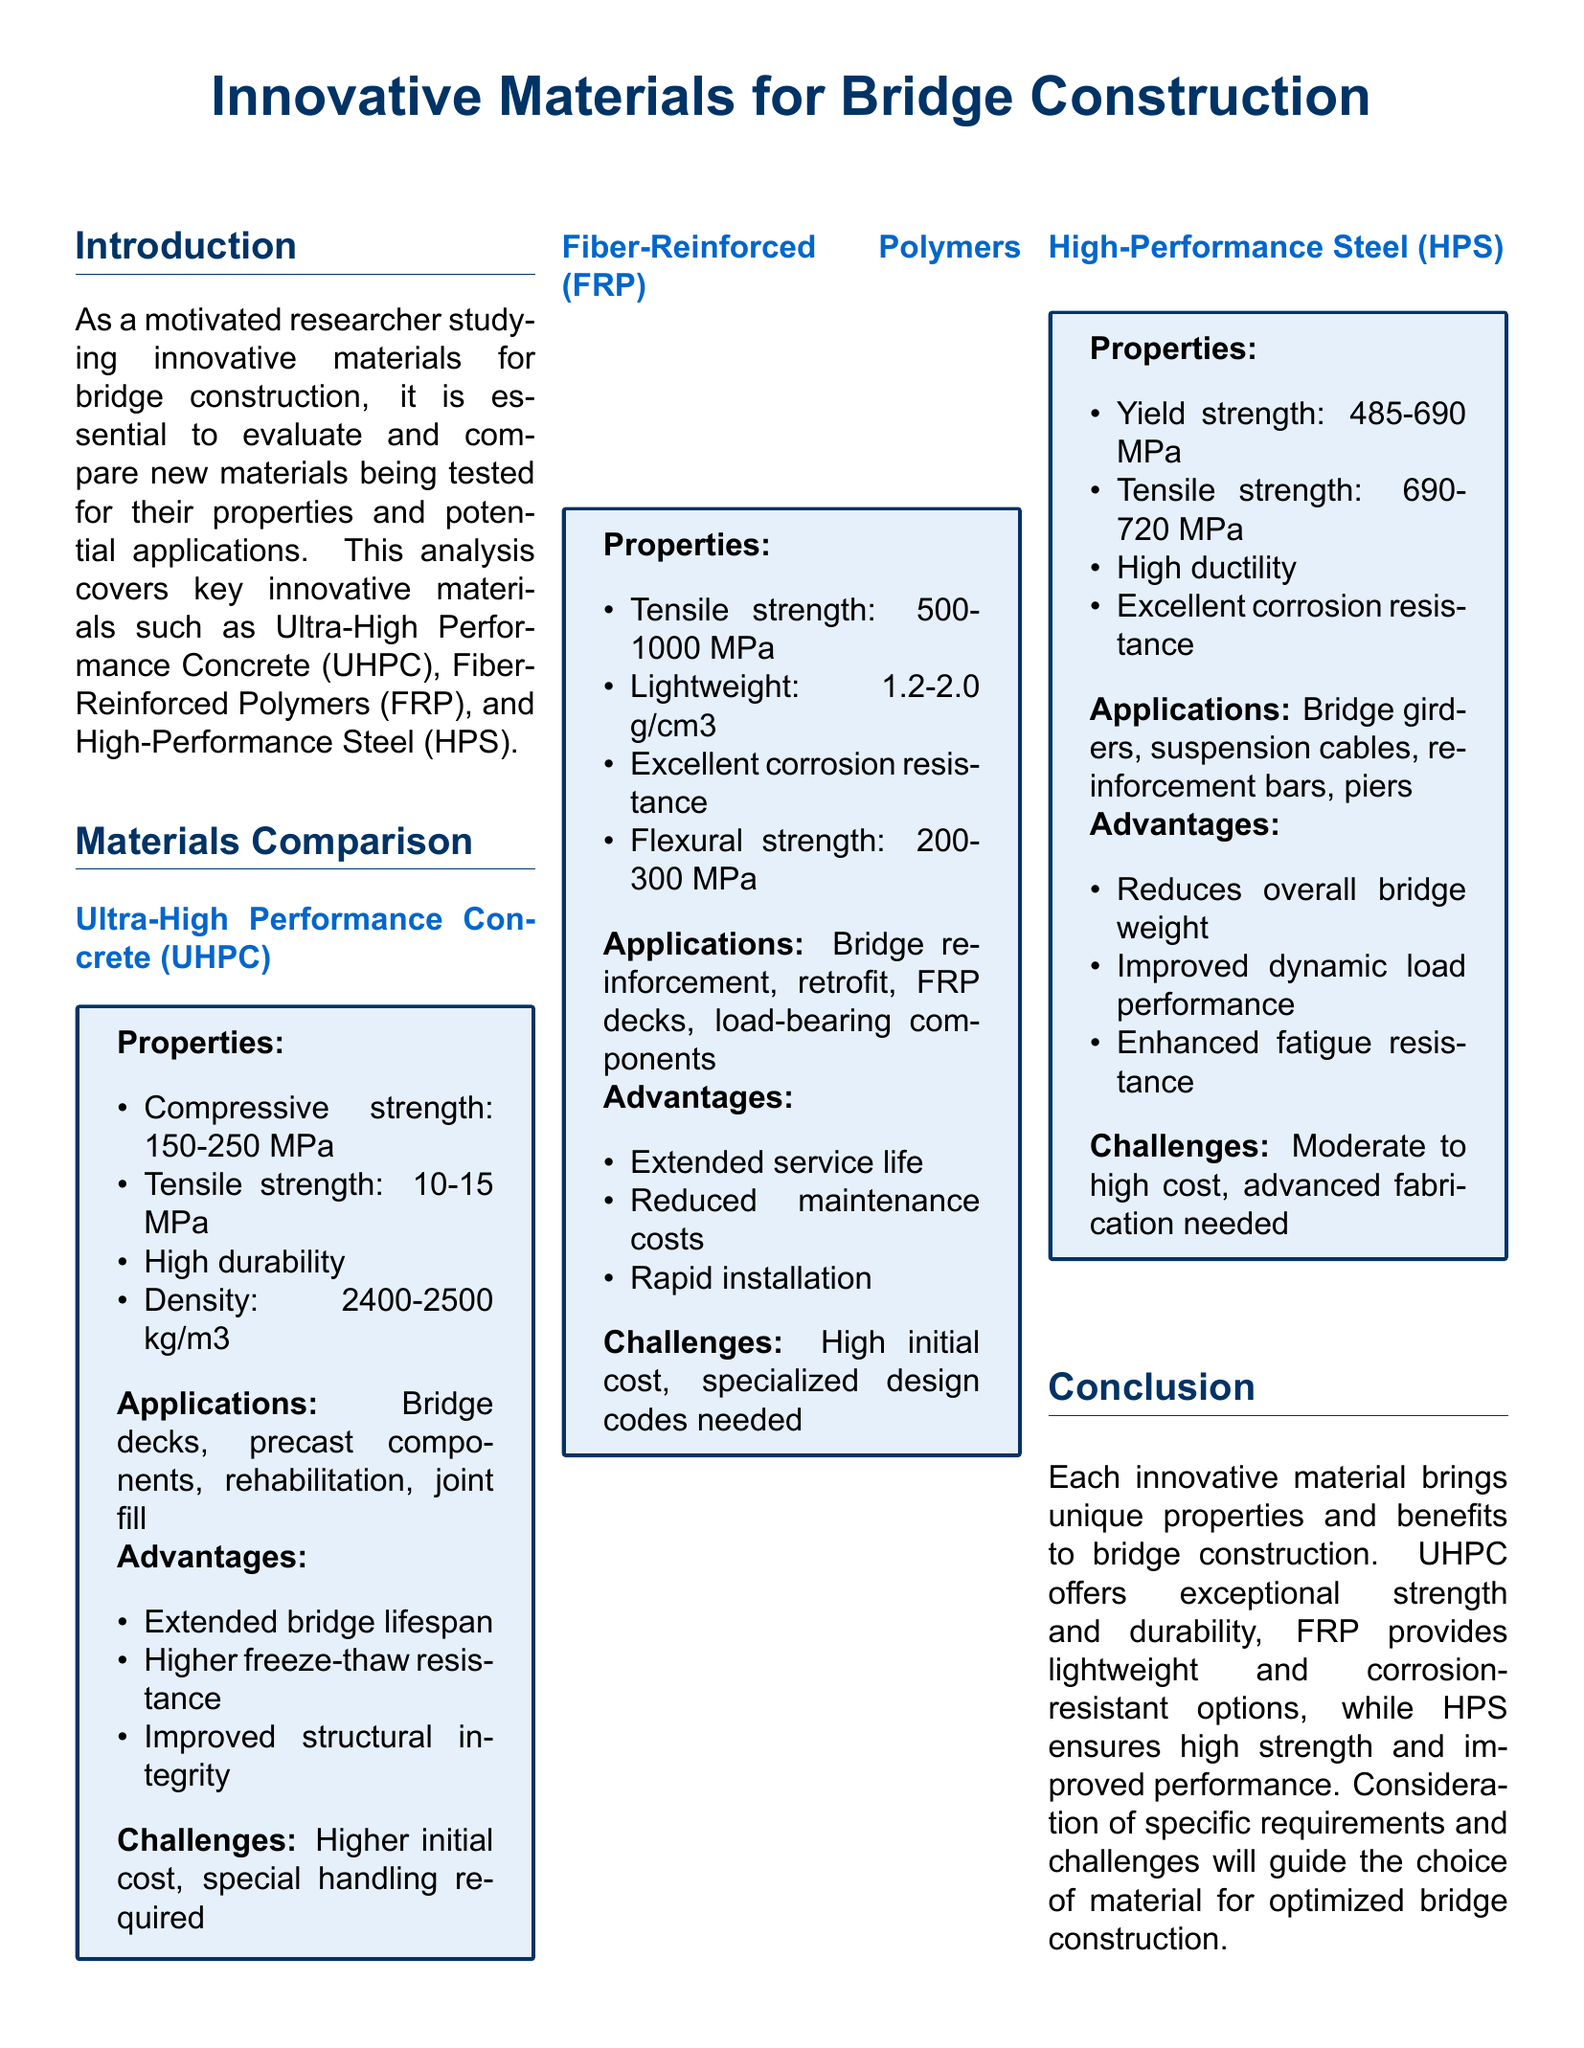what is the compressive strength of Ultra-High Performance Concrete (UHPC)? The compressive strength of UHPC ranges from 150-250 MPa.
Answer: 150-250 MPa what is the density of Fiber-Reinforced Polymers (FRP)? The density of FRP is 1.2-2.0 g/cm3.
Answer: 1.2-2.0 g/cm3 what type of bridge components can High-Performance Steel (HPS) be used for? HPS can be used for bridge girders, suspension cables, reinforcement bars, and piers.
Answer: bridge girders, suspension cables, reinforcement bars, piers which material provides excellent corrosion resistance? Fiber-Reinforced Polymers (FRP) are noted for their excellent corrosion resistance.
Answer: Fiber-Reinforced Polymers (FRP) what is a challenge associated with Ultra-High Performance Concrete (UHPC)? A challenge associated with UHPC is its higher initial cost and special handling required.
Answer: higher initial cost, special handling required how does High-Performance Steel (HPS) affect overall bridge weight? HPS reduces overall bridge weight due to its high strength properties.
Answer: reduces overall bridge weight what application is mentioned for Ultra-High Performance Concrete (UHPC)? UHPC is applied in bridge decks, precast components, rehabilitation, and joint fill.
Answer: bridge decks, precast components, rehabilitation, joint fill what are the advantages of Fiber-Reinforced Polymers (FRP)? Advantages of FRP include extended service life, reduced maintenance costs, and rapid installation.
Answer: extended service life, reduced maintenance costs, rapid installation what is the tensile strength range of High-Performance Steel (HPS)? The tensile strength of HPS ranges from 690-720 MPa.
Answer: 690-720 MPa 